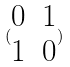<formula> <loc_0><loc_0><loc_500><loc_500>( \begin{matrix} 0 & 1 \\ 1 & 0 \end{matrix} )</formula> 